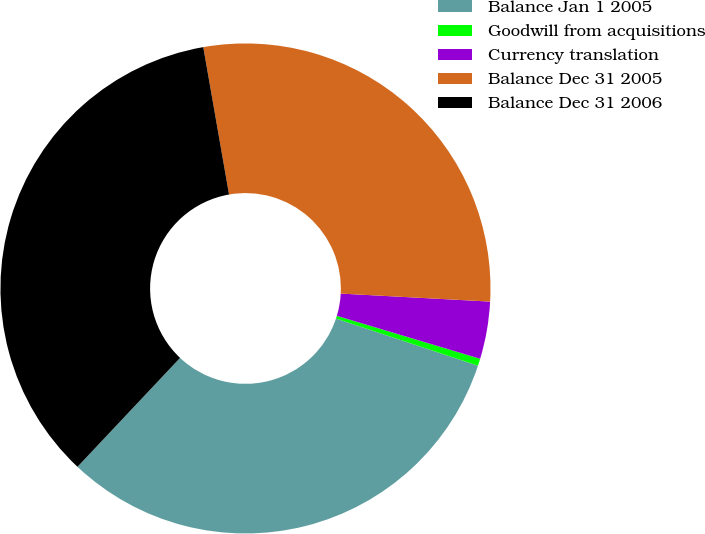Convert chart. <chart><loc_0><loc_0><loc_500><loc_500><pie_chart><fcel>Balance Jan 1 2005<fcel>Goodwill from acquisitions<fcel>Currency translation<fcel>Balance Dec 31 2005<fcel>Balance Dec 31 2006<nl><fcel>31.92%<fcel>0.47%<fcel>3.78%<fcel>28.61%<fcel>35.22%<nl></chart> 